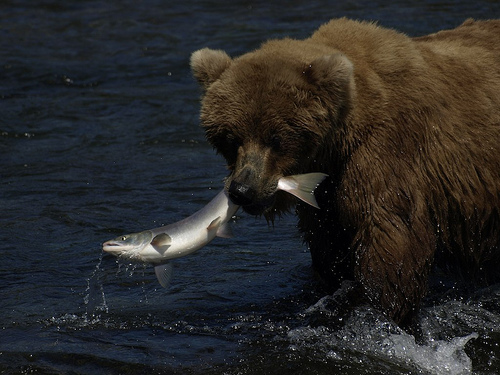What time of year do you think this photo was taken and why? Given that the bear is catching a salmon, this photo was likely taken during the summer or early fall, which is when salmon runs occur and bears are actively fishing to build up fat reserves for the winter. 